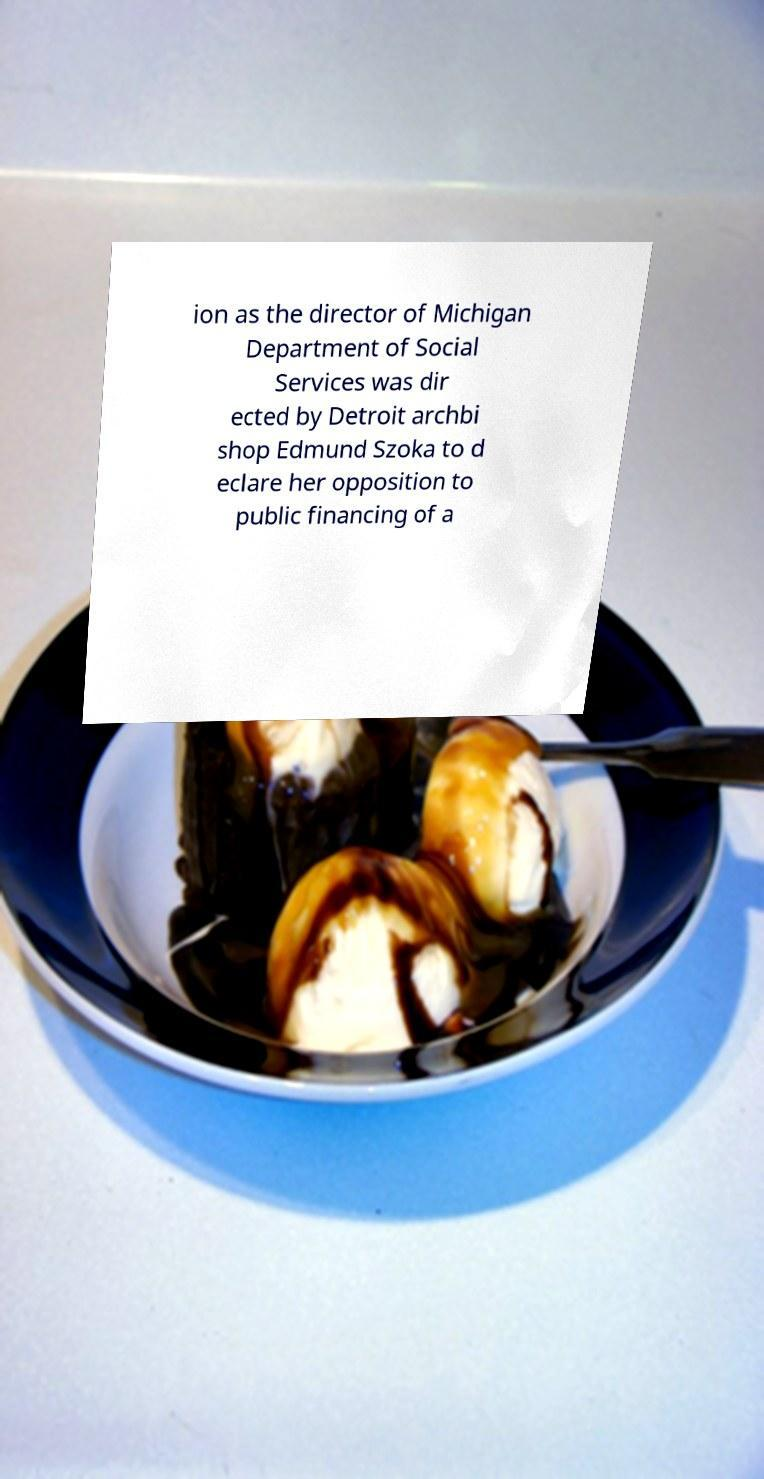Please read and relay the text visible in this image. What does it say? ion as the director of Michigan Department of Social Services was dir ected by Detroit archbi shop Edmund Szoka to d eclare her opposition to public financing of a 